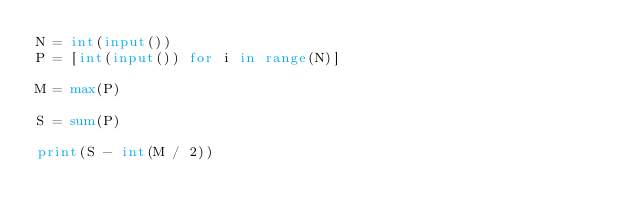<code> <loc_0><loc_0><loc_500><loc_500><_Python_>N = int(input())
P = [int(input()) for i in range(N)]

M = max(P)

S = sum(P)

print(S - int(M / 2))</code> 